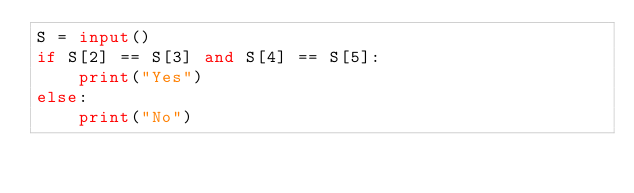Convert code to text. <code><loc_0><loc_0><loc_500><loc_500><_Python_>S = input()
if S[2] == S[3] and S[4] == S[5]:
    print("Yes")
else:
    print("No")</code> 